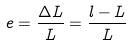Convert formula to latex. <formula><loc_0><loc_0><loc_500><loc_500>e = \frac { \Delta L } { L } = \frac { l - L } { L }</formula> 